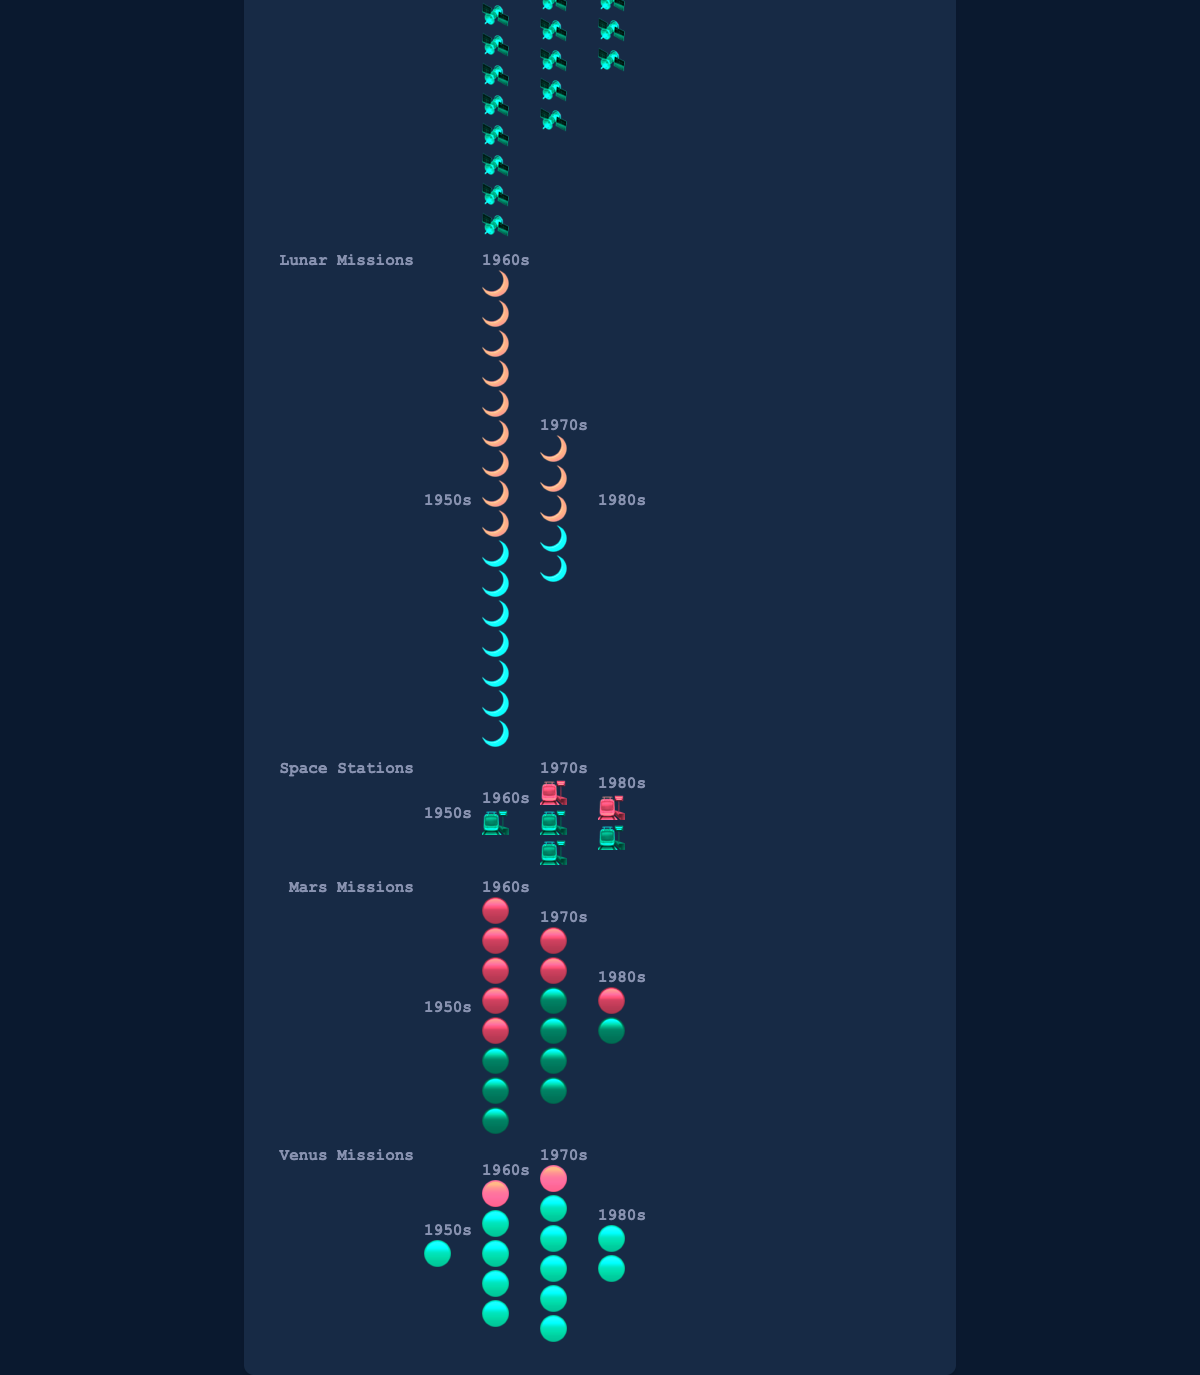What is the title of the figure? The title can be found at the top of the figure, and it states what the figure is about.
Answer: Space Race Achievements: US vs USSR How many Orbital Flights did the US achieve in the 1960s? To find this, look at the Orbital Flights row and locate the column for the 1960s. The number of icons will indicate the total count.
Answer: 10 Which side accomplished more Lunar Missions in the 1970s? Compare the number of icons for the US and the USSR in the 1970s column under the Lunar Missions row.
Answer: US In which decade did the US achieve exactly one Space Station mission? Look at the Space Stations row and find the decade where the number of icons for the US is exactly one.
Answer: 1970s and 1980s How many total Mars Missions were achieved by both the US and USSR in the 1970s? Add the number of Mars Missions icons for both the US and USSR in the 1970s column.
Answer: 6 Did the USSR have more Venus Missions than the US in the 1960s? Compare the number of icons in the Venus Missions row for the 1960s between the US and USSR.
Answer: Yes Which mission type saw both the US and USSR accomplish at least one mission in every decade? Review each mission type row to identify if both countries have at least one icon in every decade.
Answer: Orbital Flights What is the total number of Space Stations missions by the USSR across all decades? Sum the number of Space Stations icons for the USSR across all decades.
Answer: 4 Among the decades, which had the highest combined total of Orbital Flights by both the US and USSR? Calculate the sum of Orbital Flights icons for both countries in each decade and identify the highest total.
Answer: 1960s 